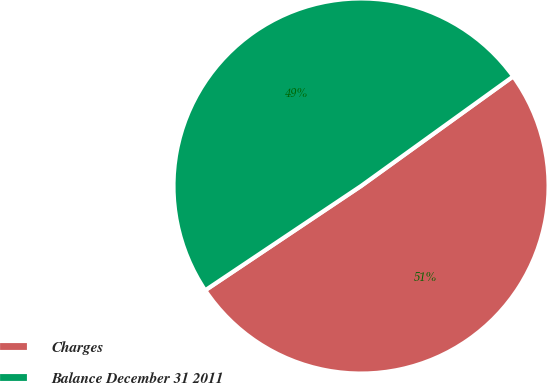<chart> <loc_0><loc_0><loc_500><loc_500><pie_chart><fcel>Charges<fcel>Balance December 31 2011<nl><fcel>50.55%<fcel>49.45%<nl></chart> 